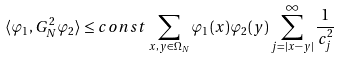Convert formula to latex. <formula><loc_0><loc_0><loc_500><loc_500>\langle \varphi _ { 1 } , G ^ { 2 } _ { N } \varphi _ { 2 } \rangle \leq c o n s t \sum _ { x , y \in \Omega _ { N } } \varphi _ { 1 } ( x ) \varphi _ { 2 } ( y ) \sum _ { j = | x - y | } ^ { \infty } \frac { 1 } { c _ { j } ^ { 2 } }</formula> 